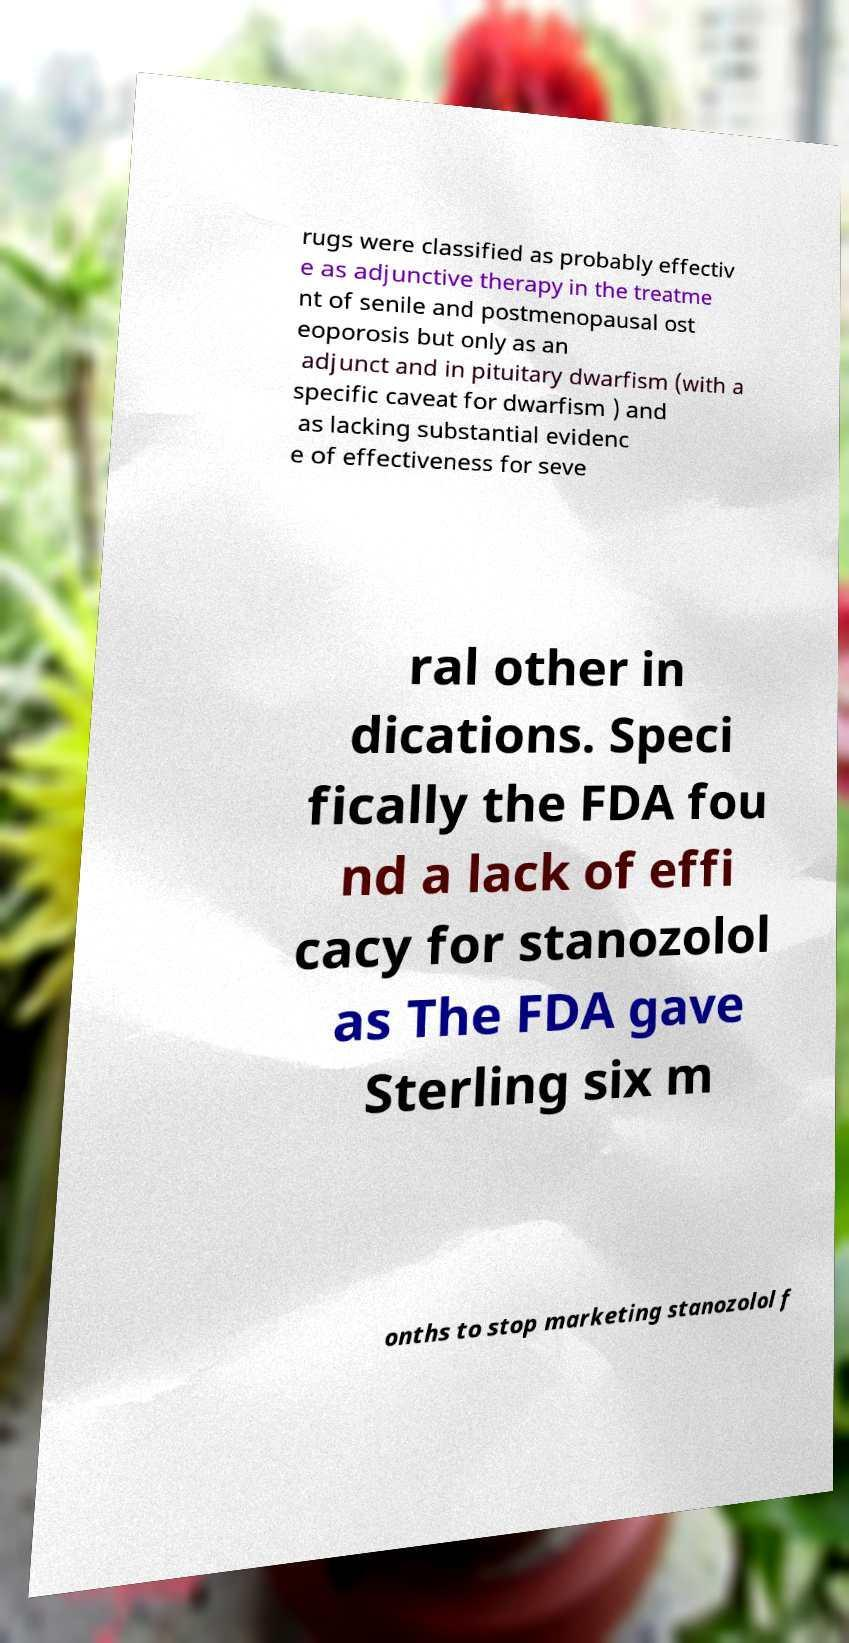Please read and relay the text visible in this image. What does it say? rugs were classified as probably effectiv e as adjunctive therapy in the treatme nt of senile and postmenopausal ost eoporosis but only as an adjunct and in pituitary dwarfism (with a specific caveat for dwarfism ) and as lacking substantial evidenc e of effectiveness for seve ral other in dications. Speci fically the FDA fou nd a lack of effi cacy for stanozolol as The FDA gave Sterling six m onths to stop marketing stanozolol f 